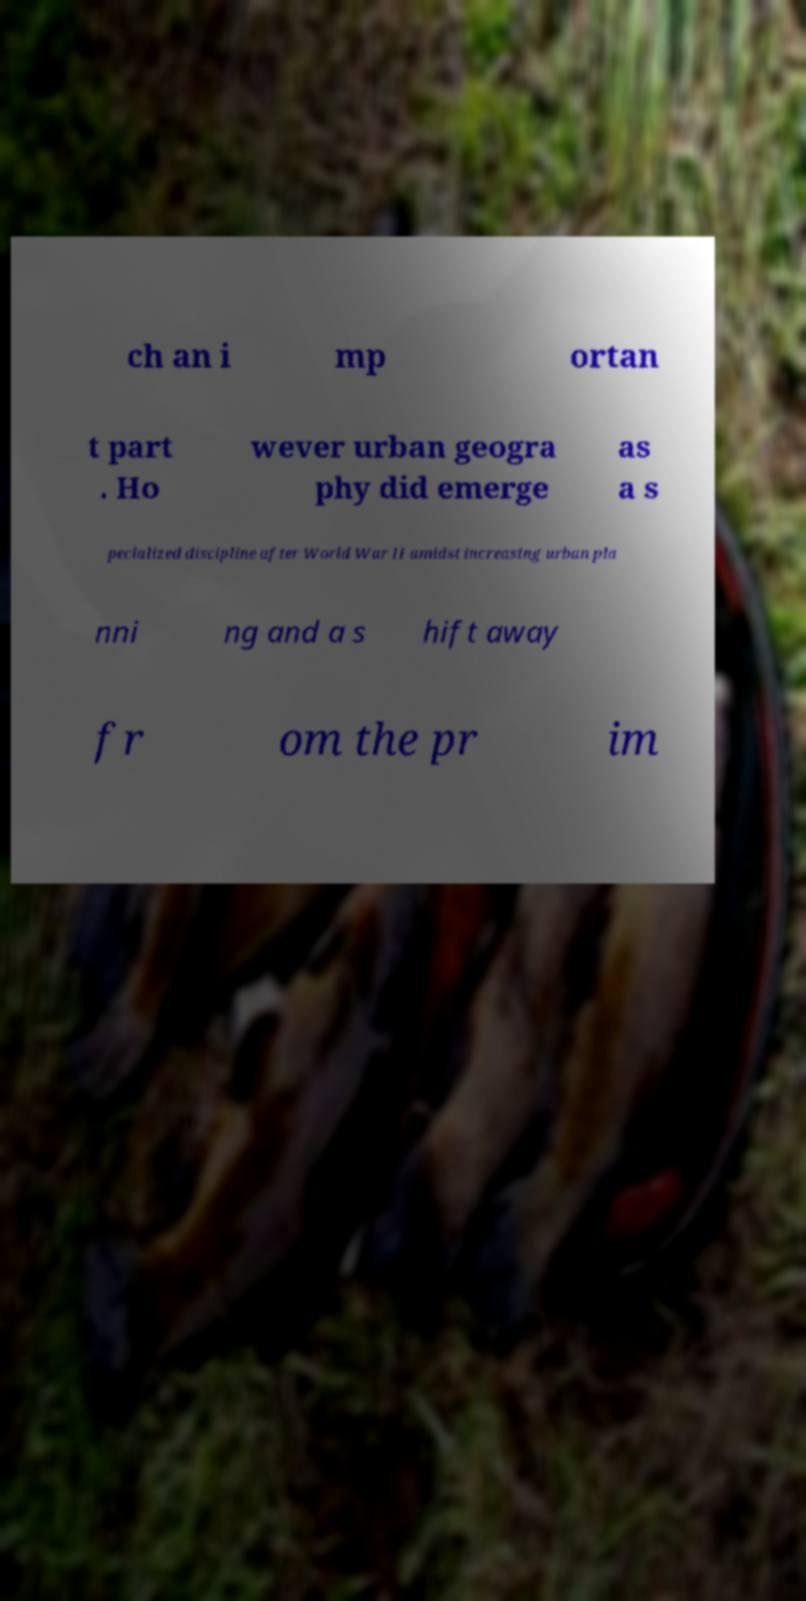Please identify and transcribe the text found in this image. ch an i mp ortan t part . Ho wever urban geogra phy did emerge as a s pecialized discipline after World War II amidst increasing urban pla nni ng and a s hift away fr om the pr im 